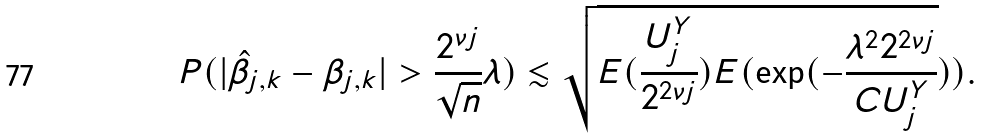<formula> <loc_0><loc_0><loc_500><loc_500>P ( | \hat { \beta } _ { j , k } - \beta _ { j , k } | > \frac { 2 ^ { \nu j } } { \sqrt { n } } \lambda ) & \lesssim \sqrt { E ( \frac { U _ { j } ^ { Y } } { 2 ^ { 2 \nu j } } ) E ( \exp ( - \frac { \lambda ^ { 2 } 2 ^ { 2 \nu j } } { C U _ { j } ^ { Y } } } ) ) .</formula> 